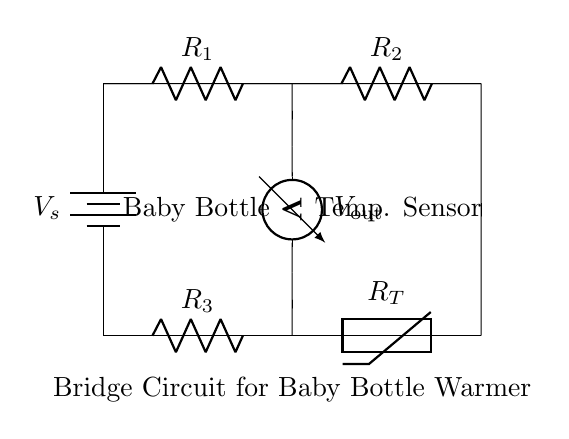What type of circuit is this? This circuit is a bridge circuit, which consists of active and passive components arranged in a way to measure or control a variable, in this case, temperature.
Answer: bridge circuit What component regulates temperature? The component that regulates temperature is the thermistor, which changes its resistance in response to temperature changes.
Answer: thermistor What is the output voltage measurement point? The output voltage is measured across the two resistors and the thermistor, specifically at the point labeled Vout in the circuit.
Answer: Vout What is the role of R1 and R2? R1 and R2 form a voltage divider that, along with the thermistor, helps balance the bridge and determine the output voltage based on temperature.
Answer: voltage divider How many resistors are there in this circuit? There are three resistors in this circuit: R1, R2, and R3.
Answer: three What happens if temperature increases? If the temperature increases, the resistance of the thermistor decreases, which affects the voltage output from the bridge, allowing the system to warm the baby bottle accordingly.
Answer: decreases resistance What is the input source for this circuit? The input source for the circuit is a battery labeled Vs providing the necessary voltage for operation.
Answer: battery 